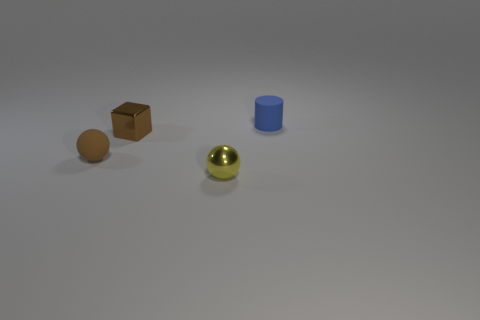Add 4 red matte cylinders. How many objects exist? 8 Subtract all cylinders. How many objects are left? 3 Subtract all yellow balls. How many balls are left? 1 Subtract 1 cubes. How many cubes are left? 0 Subtract all purple spheres. Subtract all brown blocks. How many spheres are left? 2 Subtract all blue cylinders. How many yellow spheres are left? 1 Subtract all small blue rubber things. Subtract all blue matte things. How many objects are left? 2 Add 2 matte spheres. How many matte spheres are left? 3 Add 3 tiny yellow metallic things. How many tiny yellow metallic things exist? 4 Subtract 1 yellow spheres. How many objects are left? 3 